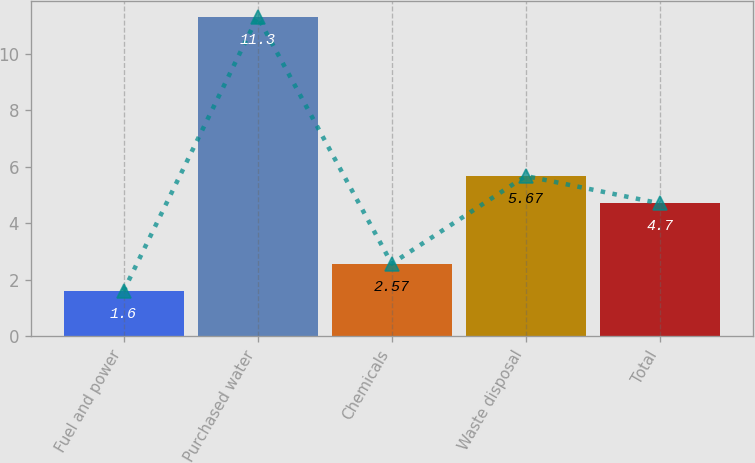Convert chart. <chart><loc_0><loc_0><loc_500><loc_500><bar_chart><fcel>Fuel and power<fcel>Purchased water<fcel>Chemicals<fcel>Waste disposal<fcel>Total<nl><fcel>1.6<fcel>11.3<fcel>2.57<fcel>5.67<fcel>4.7<nl></chart> 